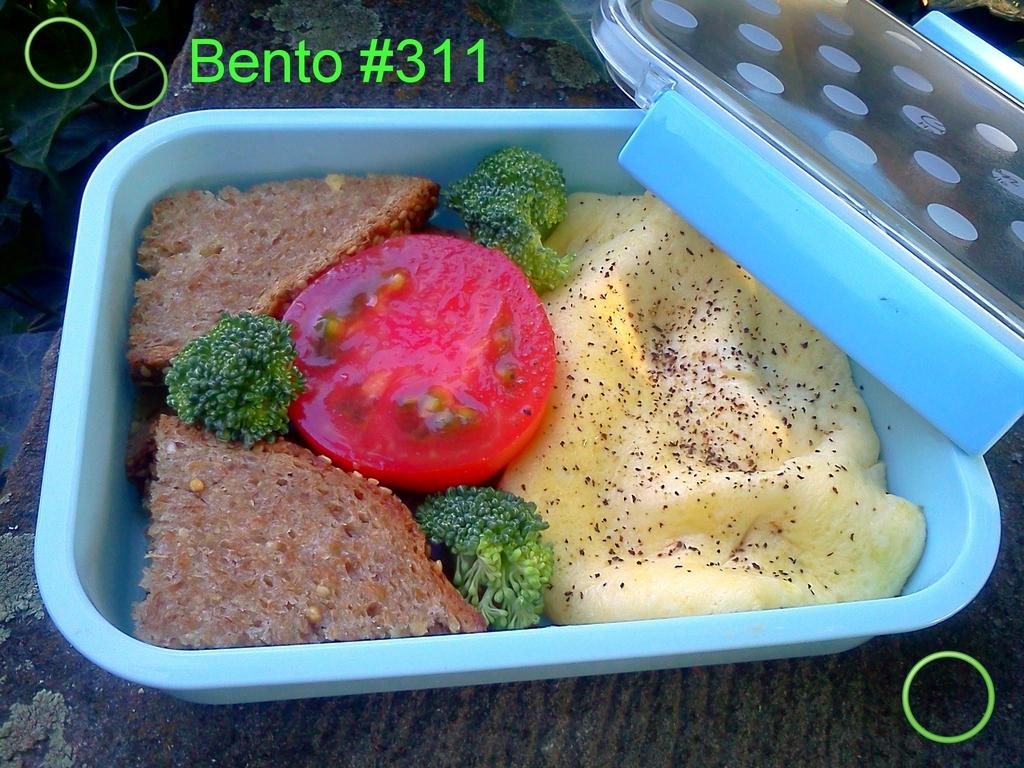What is inside the box that is visible in the image? There is a box containing food in the image, including broccoli, bread, and a tomato slice. What type of surface is the box placed on? The box is placed on a surface, but the specific type of surface is not mentioned in the facts. What can be seen on the left side of the image? There are leaves visible on the left side of the image. Can you see a girl playing on a swing in the image? There is no mention of a swing, playground, or girl in the image, so we cannot see a girl playing on a swing. 